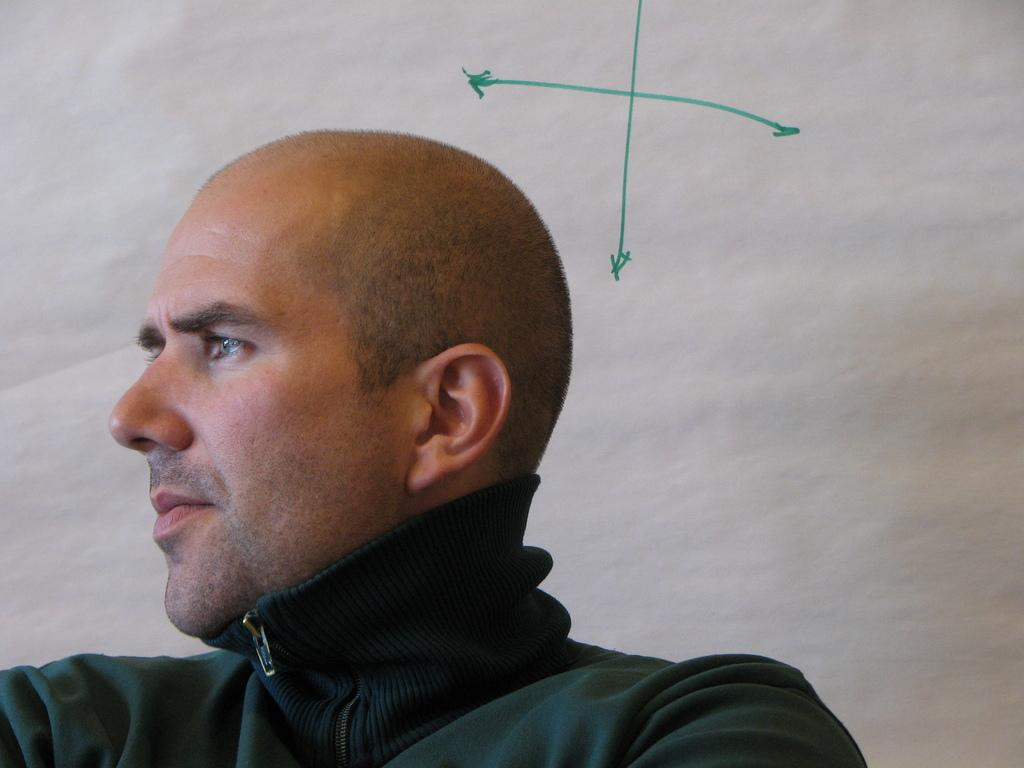Who is present in the image? There is a man in the image. What color is the background of the image? The background of the image is white. What additional elements can be seen in the image? There are arrow marks visible in the image. Does the man's sister appear in the image? There is no mention of a sister in the image, so it cannot be determined if she is present. 